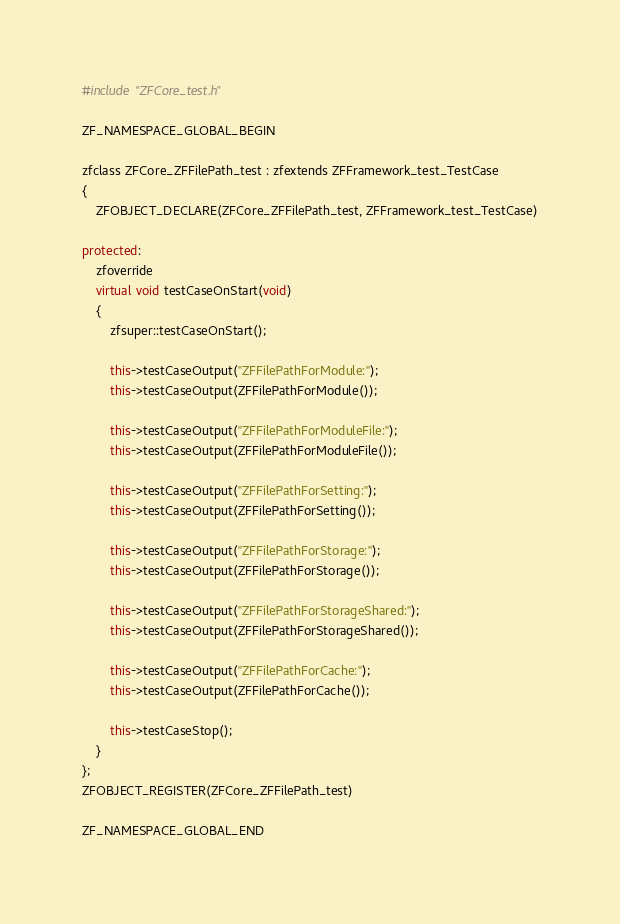<code> <loc_0><loc_0><loc_500><loc_500><_C++_>#include "ZFCore_test.h"

ZF_NAMESPACE_GLOBAL_BEGIN

zfclass ZFCore_ZFFilePath_test : zfextends ZFFramework_test_TestCase
{
    ZFOBJECT_DECLARE(ZFCore_ZFFilePath_test, ZFFramework_test_TestCase)

protected:
    zfoverride
    virtual void testCaseOnStart(void)
    {
        zfsuper::testCaseOnStart();

        this->testCaseOutput("ZFFilePathForModule:");
        this->testCaseOutput(ZFFilePathForModule());

        this->testCaseOutput("ZFFilePathForModuleFile:");
        this->testCaseOutput(ZFFilePathForModuleFile());

        this->testCaseOutput("ZFFilePathForSetting:");
        this->testCaseOutput(ZFFilePathForSetting());

        this->testCaseOutput("ZFFilePathForStorage:");
        this->testCaseOutput(ZFFilePathForStorage());

        this->testCaseOutput("ZFFilePathForStorageShared:");
        this->testCaseOutput(ZFFilePathForStorageShared());

        this->testCaseOutput("ZFFilePathForCache:");
        this->testCaseOutput(ZFFilePathForCache());

        this->testCaseStop();
    }
};
ZFOBJECT_REGISTER(ZFCore_ZFFilePath_test)

ZF_NAMESPACE_GLOBAL_END

</code> 